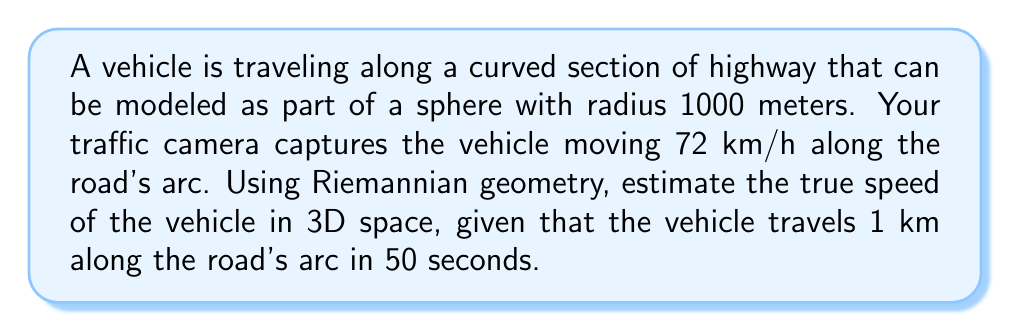Can you answer this question? To solve this problem, we'll use concepts from Riemannian geometry:

1) First, we need to understand that the vehicle's speed along the road's arc is different from its speed in 3D space due to the road's curvature.

2) The road is modeled as part of a sphere, so we'll use spherical coordinates and the corresponding metric tensor.

3) The metric tensor for a sphere of radius $R$ is:

   $$g = \begin{pmatrix} R^2 & 0 \\ 0 & R^2\sin^2\theta \end{pmatrix}$$

4) The arc length $s$ traveled on the sphere is related to the central angle $\theta$ by:

   $$s = R\theta$$

5) We're given that $s = 1$ km = 1000 m, and $R = 1000$ m. So:

   $$\theta = \frac{s}{R} = \frac{1000}{1000} = 1 \text{ radian}$$

6) The Euclidean distance $d$ between the start and end points is:

   $$d = 2R\sin(\frac{\theta}{2}) = 2(1000)\sin(\frac{1}{2}) = 958.85 \text{ m}$$

7) The time taken is 50 seconds, so the true speed in 3D space is:

   $$v = \frac{d}{t} = \frac{958.85}{50} = 19.177 \text{ m/s} = 69.04 \text{ km/h}$$

8) This is slightly less than the speed along the arc (72 km/h), as expected due to the curvature.
Answer: 69.04 km/h 